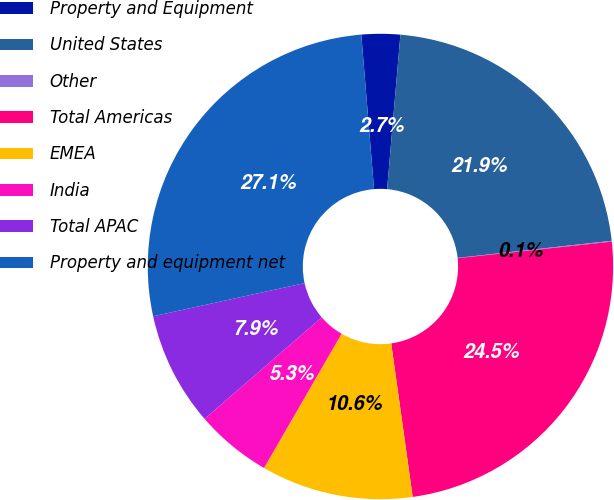Convert chart to OTSL. <chart><loc_0><loc_0><loc_500><loc_500><pie_chart><fcel>Property and Equipment<fcel>United States<fcel>Other<fcel>Total Americas<fcel>EMEA<fcel>India<fcel>Total APAC<fcel>Property and equipment net<nl><fcel>2.68%<fcel>21.87%<fcel>0.06%<fcel>24.49%<fcel>10.55%<fcel>5.3%<fcel>7.93%<fcel>27.12%<nl></chart> 